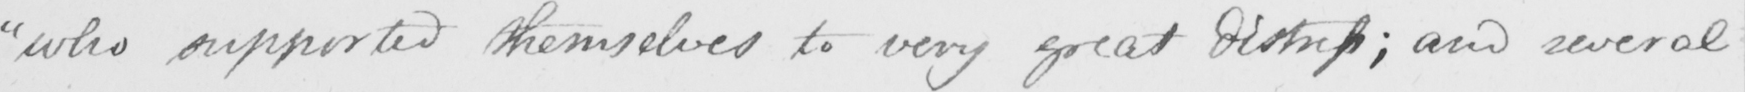Please transcribe the handwritten text in this image. " who supported themselves to very great distress ; and several 